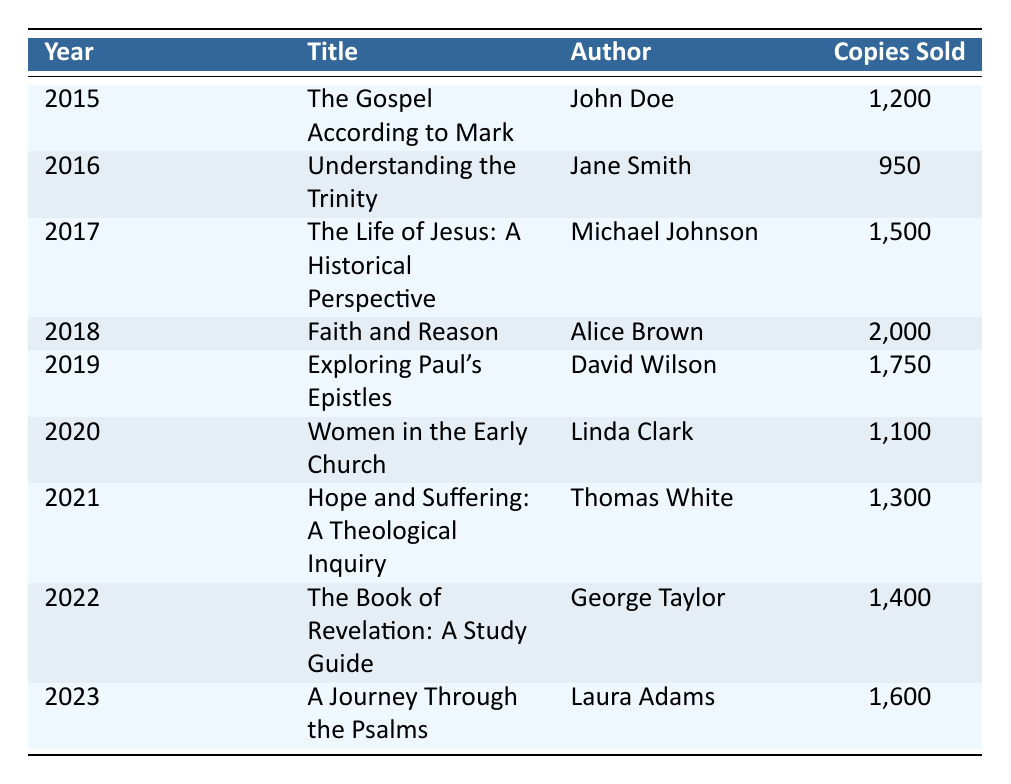What was the highest number of copies sold in a single year? The row for the year 2018 shows that "Faith and Reason" by Alice Brown sold 2,000 copies, which is the maximum in the table. By scanning through the "Copies Sold" column, it's clear that no other title exceeded this number.
Answer: 2000 Which book had the least sales? Checking the "Copies Sold" column, the book from 2016, "Understanding the Trinity" by Jane Smith, sold 950 copies, which is the lowest figure found in the table upon evaluation.
Answer: 950 What is the total number of copies sold from 2015 to 2023? To find the total, we sum the "Copies Sold" values from each year: 1200 + 950 + 1500 + 2000 + 1750 + 1100 + 1300 + 1400 + 1600 = 11500. Thus, the total number reflects the aggregate sales across all listed years.
Answer: 11500 Is there a year when more than 1500 copies were sold? Upon reviewing the "Copies Sold" data, 2018 (2,000 copies) and 2019 (1,750 copies) have figures above 1500, confirming that multiple years meet this criterion. Hence, the answer is true.
Answer: Yes What is the average number of copies sold per year from 2015 to 2023? First, calculate the total number of copies sold (11,500). Then, since we have 9 years of data (from 2015 to 2023), we divide 11,500 by 9, yielding an average of 1,277.78 copies per year. Rounding off, the average becomes approximately 1278.
Answer: 1278 